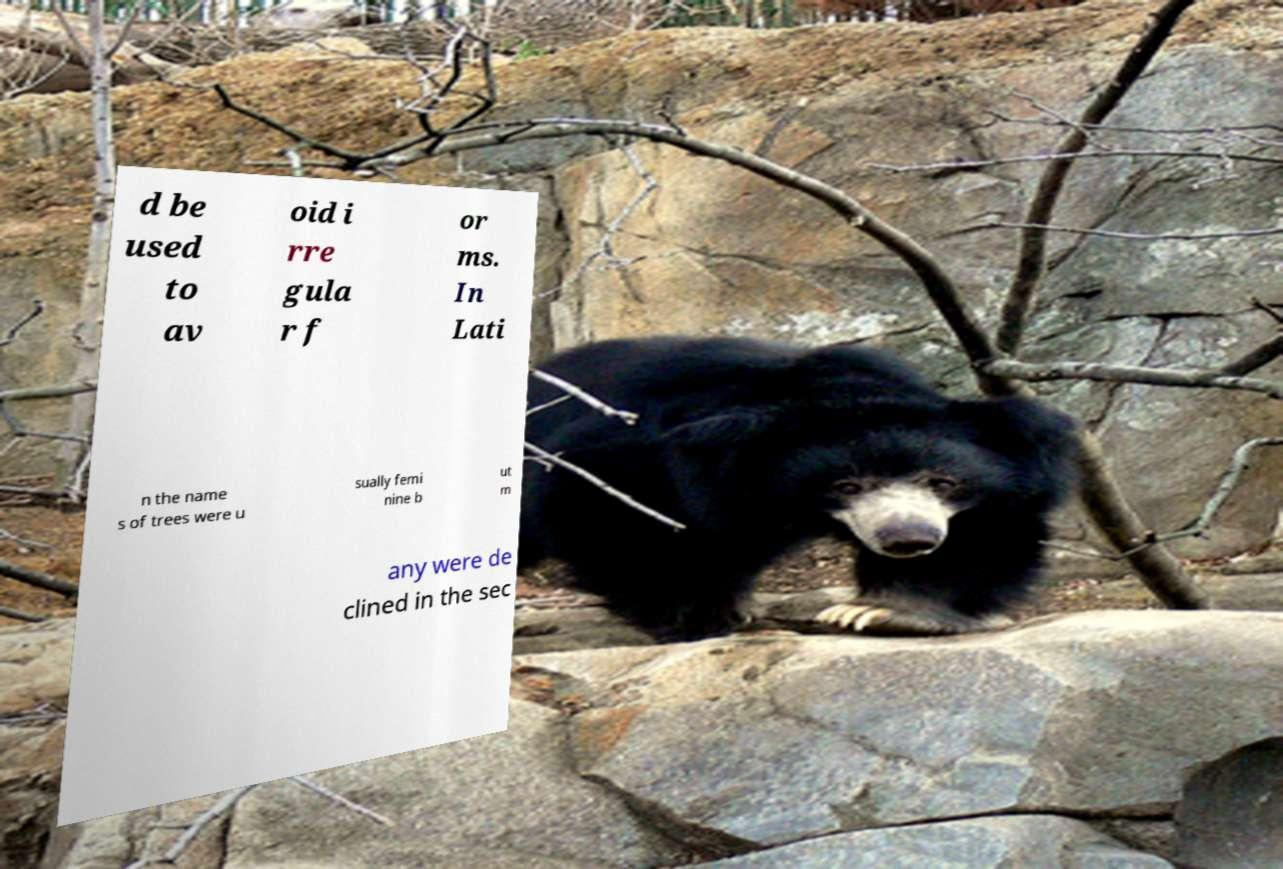Please read and relay the text visible in this image. What does it say? d be used to av oid i rre gula r f or ms. In Lati n the name s of trees were u sually femi nine b ut m any were de clined in the sec 